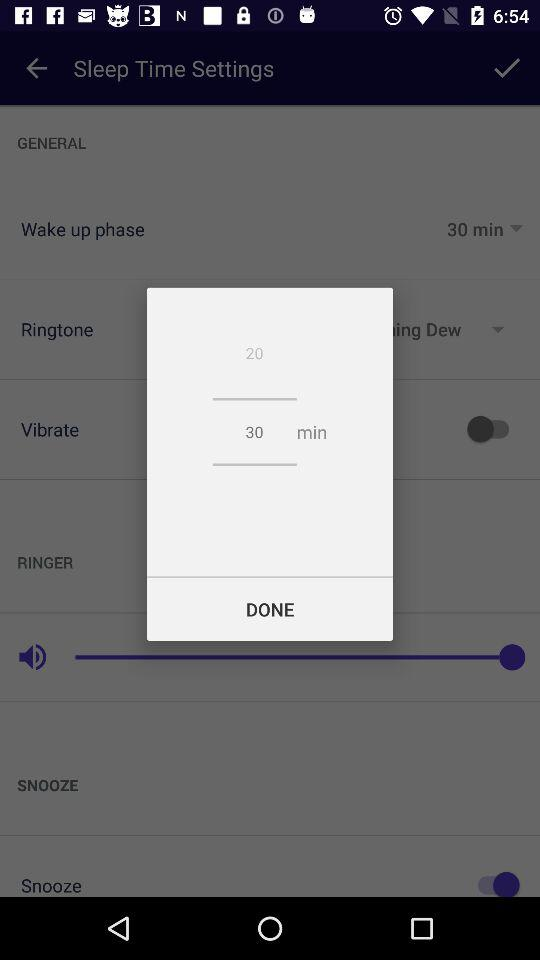What is the difference between the two numbers?
Answer the question using a single word or phrase. 10 